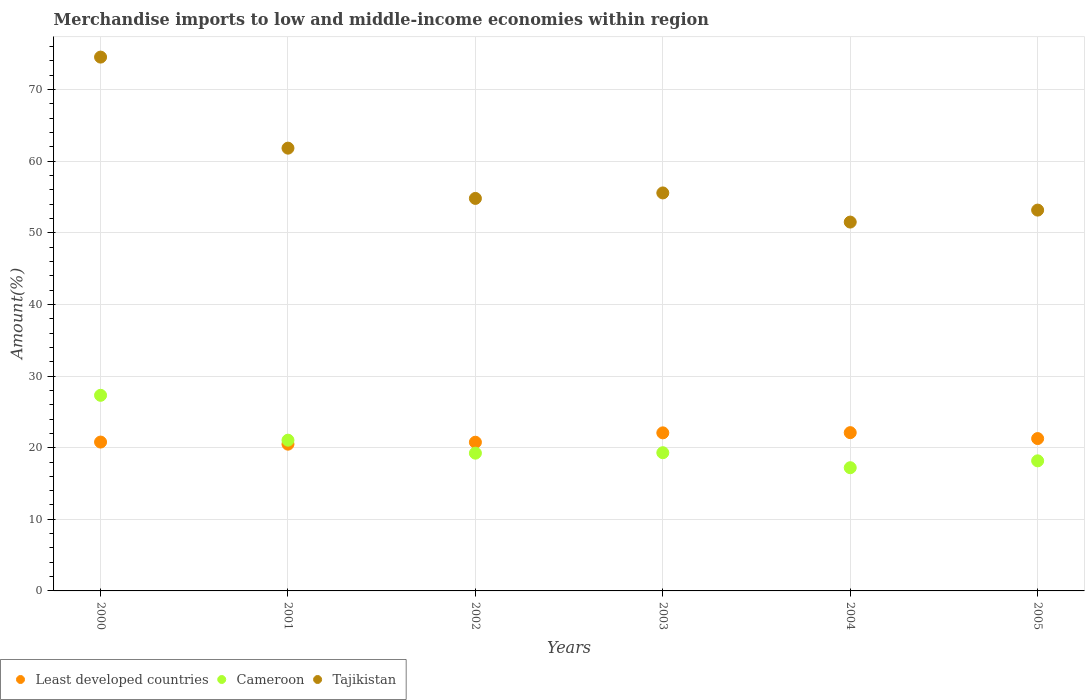Is the number of dotlines equal to the number of legend labels?
Ensure brevity in your answer.  Yes. What is the percentage of amount earned from merchandise imports in Cameroon in 2002?
Your answer should be very brief. 19.24. Across all years, what is the maximum percentage of amount earned from merchandise imports in Least developed countries?
Ensure brevity in your answer.  22.1. Across all years, what is the minimum percentage of amount earned from merchandise imports in Cameroon?
Offer a very short reply. 17.21. In which year was the percentage of amount earned from merchandise imports in Tajikistan maximum?
Ensure brevity in your answer.  2000. What is the total percentage of amount earned from merchandise imports in Cameroon in the graph?
Your response must be concise. 122.27. What is the difference between the percentage of amount earned from merchandise imports in Cameroon in 2001 and that in 2002?
Provide a succinct answer. 1.81. What is the difference between the percentage of amount earned from merchandise imports in Tajikistan in 2002 and the percentage of amount earned from merchandise imports in Least developed countries in 2000?
Provide a short and direct response. 34.02. What is the average percentage of amount earned from merchandise imports in Least developed countries per year?
Your answer should be very brief. 21.25. In the year 2002, what is the difference between the percentage of amount earned from merchandise imports in Tajikistan and percentage of amount earned from merchandise imports in Cameroon?
Your answer should be very brief. 35.57. What is the ratio of the percentage of amount earned from merchandise imports in Least developed countries in 2002 to that in 2004?
Your response must be concise. 0.94. Is the difference between the percentage of amount earned from merchandise imports in Tajikistan in 2001 and 2005 greater than the difference between the percentage of amount earned from merchandise imports in Cameroon in 2001 and 2005?
Ensure brevity in your answer.  Yes. What is the difference between the highest and the second highest percentage of amount earned from merchandise imports in Tajikistan?
Offer a very short reply. 12.71. What is the difference between the highest and the lowest percentage of amount earned from merchandise imports in Cameroon?
Provide a succinct answer. 10.11. Is the sum of the percentage of amount earned from merchandise imports in Least developed countries in 2001 and 2004 greater than the maximum percentage of amount earned from merchandise imports in Cameroon across all years?
Provide a succinct answer. Yes. Is it the case that in every year, the sum of the percentage of amount earned from merchandise imports in Cameroon and percentage of amount earned from merchandise imports in Tajikistan  is greater than the percentage of amount earned from merchandise imports in Least developed countries?
Provide a short and direct response. Yes. Is the percentage of amount earned from merchandise imports in Least developed countries strictly greater than the percentage of amount earned from merchandise imports in Cameroon over the years?
Make the answer very short. No. How many dotlines are there?
Your answer should be very brief. 3. How many years are there in the graph?
Your response must be concise. 6. What is the difference between two consecutive major ticks on the Y-axis?
Ensure brevity in your answer.  10. Does the graph contain any zero values?
Provide a succinct answer. No. How are the legend labels stacked?
Offer a very short reply. Horizontal. What is the title of the graph?
Your answer should be compact. Merchandise imports to low and middle-income economies within region. Does "Kyrgyz Republic" appear as one of the legend labels in the graph?
Provide a short and direct response. No. What is the label or title of the Y-axis?
Ensure brevity in your answer.  Amount(%). What is the Amount(%) in Least developed countries in 2000?
Provide a short and direct response. 20.79. What is the Amount(%) in Cameroon in 2000?
Offer a terse response. 27.32. What is the Amount(%) of Tajikistan in 2000?
Offer a very short reply. 74.54. What is the Amount(%) of Least developed countries in 2001?
Give a very brief answer. 20.49. What is the Amount(%) in Cameroon in 2001?
Keep it short and to the point. 21.05. What is the Amount(%) of Tajikistan in 2001?
Provide a succinct answer. 61.83. What is the Amount(%) of Least developed countries in 2002?
Offer a very short reply. 20.76. What is the Amount(%) of Cameroon in 2002?
Ensure brevity in your answer.  19.24. What is the Amount(%) of Tajikistan in 2002?
Your answer should be compact. 54.81. What is the Amount(%) of Least developed countries in 2003?
Your response must be concise. 22.07. What is the Amount(%) of Cameroon in 2003?
Your answer should be very brief. 19.3. What is the Amount(%) in Tajikistan in 2003?
Give a very brief answer. 55.57. What is the Amount(%) in Least developed countries in 2004?
Make the answer very short. 22.1. What is the Amount(%) of Cameroon in 2004?
Provide a short and direct response. 17.21. What is the Amount(%) in Tajikistan in 2004?
Your answer should be compact. 51.5. What is the Amount(%) of Least developed countries in 2005?
Offer a very short reply. 21.28. What is the Amount(%) of Cameroon in 2005?
Keep it short and to the point. 18.17. What is the Amount(%) in Tajikistan in 2005?
Ensure brevity in your answer.  53.18. Across all years, what is the maximum Amount(%) in Least developed countries?
Keep it short and to the point. 22.1. Across all years, what is the maximum Amount(%) of Cameroon?
Offer a very short reply. 27.32. Across all years, what is the maximum Amount(%) in Tajikistan?
Your answer should be compact. 74.54. Across all years, what is the minimum Amount(%) of Least developed countries?
Your response must be concise. 20.49. Across all years, what is the minimum Amount(%) in Cameroon?
Your answer should be very brief. 17.21. Across all years, what is the minimum Amount(%) of Tajikistan?
Provide a short and direct response. 51.5. What is the total Amount(%) in Least developed countries in the graph?
Keep it short and to the point. 127.49. What is the total Amount(%) of Cameroon in the graph?
Offer a terse response. 122.27. What is the total Amount(%) in Tajikistan in the graph?
Your response must be concise. 351.43. What is the difference between the Amount(%) in Least developed countries in 2000 and that in 2001?
Offer a very short reply. 0.29. What is the difference between the Amount(%) in Cameroon in 2000 and that in 2001?
Give a very brief answer. 6.27. What is the difference between the Amount(%) in Tajikistan in 2000 and that in 2001?
Give a very brief answer. 12.71. What is the difference between the Amount(%) in Least developed countries in 2000 and that in 2002?
Make the answer very short. 0.02. What is the difference between the Amount(%) in Cameroon in 2000 and that in 2002?
Your answer should be compact. 8.08. What is the difference between the Amount(%) in Tajikistan in 2000 and that in 2002?
Your answer should be compact. 19.73. What is the difference between the Amount(%) of Least developed countries in 2000 and that in 2003?
Offer a terse response. -1.29. What is the difference between the Amount(%) in Cameroon in 2000 and that in 2003?
Make the answer very short. 8.02. What is the difference between the Amount(%) of Tajikistan in 2000 and that in 2003?
Make the answer very short. 18.97. What is the difference between the Amount(%) of Least developed countries in 2000 and that in 2004?
Provide a succinct answer. -1.32. What is the difference between the Amount(%) in Cameroon in 2000 and that in 2004?
Provide a short and direct response. 10.11. What is the difference between the Amount(%) of Tajikistan in 2000 and that in 2004?
Keep it short and to the point. 23.04. What is the difference between the Amount(%) in Least developed countries in 2000 and that in 2005?
Your answer should be compact. -0.49. What is the difference between the Amount(%) in Cameroon in 2000 and that in 2005?
Make the answer very short. 9.15. What is the difference between the Amount(%) in Tajikistan in 2000 and that in 2005?
Keep it short and to the point. 21.36. What is the difference between the Amount(%) in Least developed countries in 2001 and that in 2002?
Give a very brief answer. -0.27. What is the difference between the Amount(%) of Cameroon in 2001 and that in 2002?
Offer a terse response. 1.81. What is the difference between the Amount(%) in Tajikistan in 2001 and that in 2002?
Provide a short and direct response. 7.02. What is the difference between the Amount(%) of Least developed countries in 2001 and that in 2003?
Provide a succinct answer. -1.58. What is the difference between the Amount(%) of Cameroon in 2001 and that in 2003?
Your answer should be very brief. 1.75. What is the difference between the Amount(%) of Tajikistan in 2001 and that in 2003?
Provide a short and direct response. 6.25. What is the difference between the Amount(%) of Least developed countries in 2001 and that in 2004?
Offer a very short reply. -1.61. What is the difference between the Amount(%) in Cameroon in 2001 and that in 2004?
Keep it short and to the point. 3.84. What is the difference between the Amount(%) of Tajikistan in 2001 and that in 2004?
Provide a succinct answer. 10.32. What is the difference between the Amount(%) in Least developed countries in 2001 and that in 2005?
Your answer should be very brief. -0.78. What is the difference between the Amount(%) in Cameroon in 2001 and that in 2005?
Your answer should be compact. 2.88. What is the difference between the Amount(%) of Tajikistan in 2001 and that in 2005?
Your answer should be compact. 8.65. What is the difference between the Amount(%) in Least developed countries in 2002 and that in 2003?
Ensure brevity in your answer.  -1.31. What is the difference between the Amount(%) in Cameroon in 2002 and that in 2003?
Keep it short and to the point. -0.06. What is the difference between the Amount(%) of Tajikistan in 2002 and that in 2003?
Provide a short and direct response. -0.77. What is the difference between the Amount(%) of Least developed countries in 2002 and that in 2004?
Your answer should be very brief. -1.34. What is the difference between the Amount(%) in Cameroon in 2002 and that in 2004?
Keep it short and to the point. 2.03. What is the difference between the Amount(%) of Tajikistan in 2002 and that in 2004?
Make the answer very short. 3.3. What is the difference between the Amount(%) in Least developed countries in 2002 and that in 2005?
Provide a succinct answer. -0.51. What is the difference between the Amount(%) of Cameroon in 2002 and that in 2005?
Ensure brevity in your answer.  1.07. What is the difference between the Amount(%) in Tajikistan in 2002 and that in 2005?
Keep it short and to the point. 1.63. What is the difference between the Amount(%) of Least developed countries in 2003 and that in 2004?
Offer a very short reply. -0.03. What is the difference between the Amount(%) of Cameroon in 2003 and that in 2004?
Your answer should be compact. 2.09. What is the difference between the Amount(%) in Tajikistan in 2003 and that in 2004?
Your response must be concise. 4.07. What is the difference between the Amount(%) of Least developed countries in 2003 and that in 2005?
Provide a short and direct response. 0.8. What is the difference between the Amount(%) of Cameroon in 2003 and that in 2005?
Your response must be concise. 1.13. What is the difference between the Amount(%) of Tajikistan in 2003 and that in 2005?
Your answer should be compact. 2.4. What is the difference between the Amount(%) of Least developed countries in 2004 and that in 2005?
Your response must be concise. 0.83. What is the difference between the Amount(%) in Cameroon in 2004 and that in 2005?
Provide a succinct answer. -0.96. What is the difference between the Amount(%) of Tajikistan in 2004 and that in 2005?
Give a very brief answer. -1.67. What is the difference between the Amount(%) of Least developed countries in 2000 and the Amount(%) of Cameroon in 2001?
Provide a succinct answer. -0.26. What is the difference between the Amount(%) of Least developed countries in 2000 and the Amount(%) of Tajikistan in 2001?
Provide a short and direct response. -41.04. What is the difference between the Amount(%) of Cameroon in 2000 and the Amount(%) of Tajikistan in 2001?
Your answer should be very brief. -34.51. What is the difference between the Amount(%) of Least developed countries in 2000 and the Amount(%) of Cameroon in 2002?
Provide a short and direct response. 1.55. What is the difference between the Amount(%) in Least developed countries in 2000 and the Amount(%) in Tajikistan in 2002?
Keep it short and to the point. -34.02. What is the difference between the Amount(%) of Cameroon in 2000 and the Amount(%) of Tajikistan in 2002?
Ensure brevity in your answer.  -27.49. What is the difference between the Amount(%) in Least developed countries in 2000 and the Amount(%) in Cameroon in 2003?
Provide a succinct answer. 1.49. What is the difference between the Amount(%) of Least developed countries in 2000 and the Amount(%) of Tajikistan in 2003?
Your answer should be very brief. -34.79. What is the difference between the Amount(%) in Cameroon in 2000 and the Amount(%) in Tajikistan in 2003?
Your answer should be very brief. -28.26. What is the difference between the Amount(%) of Least developed countries in 2000 and the Amount(%) of Cameroon in 2004?
Make the answer very short. 3.58. What is the difference between the Amount(%) of Least developed countries in 2000 and the Amount(%) of Tajikistan in 2004?
Ensure brevity in your answer.  -30.72. What is the difference between the Amount(%) of Cameroon in 2000 and the Amount(%) of Tajikistan in 2004?
Offer a very short reply. -24.19. What is the difference between the Amount(%) in Least developed countries in 2000 and the Amount(%) in Cameroon in 2005?
Your answer should be very brief. 2.62. What is the difference between the Amount(%) of Least developed countries in 2000 and the Amount(%) of Tajikistan in 2005?
Your answer should be compact. -32.39. What is the difference between the Amount(%) in Cameroon in 2000 and the Amount(%) in Tajikistan in 2005?
Provide a short and direct response. -25.86. What is the difference between the Amount(%) in Least developed countries in 2001 and the Amount(%) in Cameroon in 2002?
Keep it short and to the point. 1.26. What is the difference between the Amount(%) in Least developed countries in 2001 and the Amount(%) in Tajikistan in 2002?
Offer a terse response. -34.32. What is the difference between the Amount(%) of Cameroon in 2001 and the Amount(%) of Tajikistan in 2002?
Make the answer very short. -33.76. What is the difference between the Amount(%) in Least developed countries in 2001 and the Amount(%) in Cameroon in 2003?
Your response must be concise. 1.19. What is the difference between the Amount(%) of Least developed countries in 2001 and the Amount(%) of Tajikistan in 2003?
Ensure brevity in your answer.  -35.08. What is the difference between the Amount(%) in Cameroon in 2001 and the Amount(%) in Tajikistan in 2003?
Keep it short and to the point. -34.52. What is the difference between the Amount(%) in Least developed countries in 2001 and the Amount(%) in Cameroon in 2004?
Offer a very short reply. 3.29. What is the difference between the Amount(%) of Least developed countries in 2001 and the Amount(%) of Tajikistan in 2004?
Offer a very short reply. -31.01. What is the difference between the Amount(%) of Cameroon in 2001 and the Amount(%) of Tajikistan in 2004?
Make the answer very short. -30.45. What is the difference between the Amount(%) of Least developed countries in 2001 and the Amount(%) of Cameroon in 2005?
Make the answer very short. 2.33. What is the difference between the Amount(%) of Least developed countries in 2001 and the Amount(%) of Tajikistan in 2005?
Provide a short and direct response. -32.68. What is the difference between the Amount(%) of Cameroon in 2001 and the Amount(%) of Tajikistan in 2005?
Keep it short and to the point. -32.13. What is the difference between the Amount(%) of Least developed countries in 2002 and the Amount(%) of Cameroon in 2003?
Offer a very short reply. 1.46. What is the difference between the Amount(%) in Least developed countries in 2002 and the Amount(%) in Tajikistan in 2003?
Ensure brevity in your answer.  -34.81. What is the difference between the Amount(%) in Cameroon in 2002 and the Amount(%) in Tajikistan in 2003?
Provide a short and direct response. -36.34. What is the difference between the Amount(%) in Least developed countries in 2002 and the Amount(%) in Cameroon in 2004?
Provide a succinct answer. 3.56. What is the difference between the Amount(%) in Least developed countries in 2002 and the Amount(%) in Tajikistan in 2004?
Provide a short and direct response. -30.74. What is the difference between the Amount(%) of Cameroon in 2002 and the Amount(%) of Tajikistan in 2004?
Your answer should be very brief. -32.27. What is the difference between the Amount(%) of Least developed countries in 2002 and the Amount(%) of Cameroon in 2005?
Give a very brief answer. 2.6. What is the difference between the Amount(%) of Least developed countries in 2002 and the Amount(%) of Tajikistan in 2005?
Your response must be concise. -32.41. What is the difference between the Amount(%) in Cameroon in 2002 and the Amount(%) in Tajikistan in 2005?
Make the answer very short. -33.94. What is the difference between the Amount(%) of Least developed countries in 2003 and the Amount(%) of Cameroon in 2004?
Offer a very short reply. 4.87. What is the difference between the Amount(%) of Least developed countries in 2003 and the Amount(%) of Tajikistan in 2004?
Keep it short and to the point. -29.43. What is the difference between the Amount(%) in Cameroon in 2003 and the Amount(%) in Tajikistan in 2004?
Ensure brevity in your answer.  -32.21. What is the difference between the Amount(%) of Least developed countries in 2003 and the Amount(%) of Cameroon in 2005?
Ensure brevity in your answer.  3.91. What is the difference between the Amount(%) in Least developed countries in 2003 and the Amount(%) in Tajikistan in 2005?
Provide a succinct answer. -31.1. What is the difference between the Amount(%) in Cameroon in 2003 and the Amount(%) in Tajikistan in 2005?
Ensure brevity in your answer.  -33.88. What is the difference between the Amount(%) of Least developed countries in 2004 and the Amount(%) of Cameroon in 2005?
Provide a succinct answer. 3.94. What is the difference between the Amount(%) in Least developed countries in 2004 and the Amount(%) in Tajikistan in 2005?
Your response must be concise. -31.07. What is the difference between the Amount(%) in Cameroon in 2004 and the Amount(%) in Tajikistan in 2005?
Ensure brevity in your answer.  -35.97. What is the average Amount(%) of Least developed countries per year?
Offer a very short reply. 21.25. What is the average Amount(%) in Cameroon per year?
Your response must be concise. 20.38. What is the average Amount(%) of Tajikistan per year?
Make the answer very short. 58.57. In the year 2000, what is the difference between the Amount(%) of Least developed countries and Amount(%) of Cameroon?
Your answer should be compact. -6.53. In the year 2000, what is the difference between the Amount(%) in Least developed countries and Amount(%) in Tajikistan?
Offer a very short reply. -53.76. In the year 2000, what is the difference between the Amount(%) of Cameroon and Amount(%) of Tajikistan?
Offer a terse response. -47.23. In the year 2001, what is the difference between the Amount(%) of Least developed countries and Amount(%) of Cameroon?
Offer a very short reply. -0.56. In the year 2001, what is the difference between the Amount(%) of Least developed countries and Amount(%) of Tajikistan?
Offer a terse response. -41.33. In the year 2001, what is the difference between the Amount(%) of Cameroon and Amount(%) of Tajikistan?
Your response must be concise. -40.78. In the year 2002, what is the difference between the Amount(%) of Least developed countries and Amount(%) of Cameroon?
Keep it short and to the point. 1.53. In the year 2002, what is the difference between the Amount(%) of Least developed countries and Amount(%) of Tajikistan?
Provide a short and direct response. -34.05. In the year 2002, what is the difference between the Amount(%) in Cameroon and Amount(%) in Tajikistan?
Make the answer very short. -35.57. In the year 2003, what is the difference between the Amount(%) of Least developed countries and Amount(%) of Cameroon?
Give a very brief answer. 2.77. In the year 2003, what is the difference between the Amount(%) of Least developed countries and Amount(%) of Tajikistan?
Make the answer very short. -33.5. In the year 2003, what is the difference between the Amount(%) in Cameroon and Amount(%) in Tajikistan?
Provide a short and direct response. -36.28. In the year 2004, what is the difference between the Amount(%) of Least developed countries and Amount(%) of Cameroon?
Keep it short and to the point. 4.9. In the year 2004, what is the difference between the Amount(%) in Least developed countries and Amount(%) in Tajikistan?
Your answer should be compact. -29.4. In the year 2004, what is the difference between the Amount(%) in Cameroon and Amount(%) in Tajikistan?
Ensure brevity in your answer.  -34.3. In the year 2005, what is the difference between the Amount(%) of Least developed countries and Amount(%) of Cameroon?
Offer a terse response. 3.11. In the year 2005, what is the difference between the Amount(%) of Least developed countries and Amount(%) of Tajikistan?
Give a very brief answer. -31.9. In the year 2005, what is the difference between the Amount(%) of Cameroon and Amount(%) of Tajikistan?
Keep it short and to the point. -35.01. What is the ratio of the Amount(%) of Least developed countries in 2000 to that in 2001?
Give a very brief answer. 1.01. What is the ratio of the Amount(%) in Cameroon in 2000 to that in 2001?
Ensure brevity in your answer.  1.3. What is the ratio of the Amount(%) in Tajikistan in 2000 to that in 2001?
Make the answer very short. 1.21. What is the ratio of the Amount(%) of Cameroon in 2000 to that in 2002?
Ensure brevity in your answer.  1.42. What is the ratio of the Amount(%) of Tajikistan in 2000 to that in 2002?
Your response must be concise. 1.36. What is the ratio of the Amount(%) of Least developed countries in 2000 to that in 2003?
Your answer should be compact. 0.94. What is the ratio of the Amount(%) in Cameroon in 2000 to that in 2003?
Make the answer very short. 1.42. What is the ratio of the Amount(%) in Tajikistan in 2000 to that in 2003?
Provide a short and direct response. 1.34. What is the ratio of the Amount(%) in Least developed countries in 2000 to that in 2004?
Provide a short and direct response. 0.94. What is the ratio of the Amount(%) of Cameroon in 2000 to that in 2004?
Keep it short and to the point. 1.59. What is the ratio of the Amount(%) of Tajikistan in 2000 to that in 2004?
Give a very brief answer. 1.45. What is the ratio of the Amount(%) in Least developed countries in 2000 to that in 2005?
Provide a short and direct response. 0.98. What is the ratio of the Amount(%) in Cameroon in 2000 to that in 2005?
Your response must be concise. 1.5. What is the ratio of the Amount(%) in Tajikistan in 2000 to that in 2005?
Your response must be concise. 1.4. What is the ratio of the Amount(%) of Cameroon in 2001 to that in 2002?
Provide a succinct answer. 1.09. What is the ratio of the Amount(%) of Tajikistan in 2001 to that in 2002?
Make the answer very short. 1.13. What is the ratio of the Amount(%) in Least developed countries in 2001 to that in 2003?
Offer a very short reply. 0.93. What is the ratio of the Amount(%) in Cameroon in 2001 to that in 2003?
Your response must be concise. 1.09. What is the ratio of the Amount(%) of Tajikistan in 2001 to that in 2003?
Make the answer very short. 1.11. What is the ratio of the Amount(%) of Least developed countries in 2001 to that in 2004?
Your answer should be very brief. 0.93. What is the ratio of the Amount(%) in Cameroon in 2001 to that in 2004?
Provide a succinct answer. 1.22. What is the ratio of the Amount(%) in Tajikistan in 2001 to that in 2004?
Give a very brief answer. 1.2. What is the ratio of the Amount(%) of Least developed countries in 2001 to that in 2005?
Give a very brief answer. 0.96. What is the ratio of the Amount(%) in Cameroon in 2001 to that in 2005?
Your response must be concise. 1.16. What is the ratio of the Amount(%) of Tajikistan in 2001 to that in 2005?
Give a very brief answer. 1.16. What is the ratio of the Amount(%) of Least developed countries in 2002 to that in 2003?
Make the answer very short. 0.94. What is the ratio of the Amount(%) in Cameroon in 2002 to that in 2003?
Give a very brief answer. 1. What is the ratio of the Amount(%) of Tajikistan in 2002 to that in 2003?
Keep it short and to the point. 0.99. What is the ratio of the Amount(%) in Least developed countries in 2002 to that in 2004?
Your answer should be compact. 0.94. What is the ratio of the Amount(%) in Cameroon in 2002 to that in 2004?
Your response must be concise. 1.12. What is the ratio of the Amount(%) in Tajikistan in 2002 to that in 2004?
Keep it short and to the point. 1.06. What is the ratio of the Amount(%) of Least developed countries in 2002 to that in 2005?
Your answer should be very brief. 0.98. What is the ratio of the Amount(%) of Cameroon in 2002 to that in 2005?
Provide a succinct answer. 1.06. What is the ratio of the Amount(%) of Tajikistan in 2002 to that in 2005?
Ensure brevity in your answer.  1.03. What is the ratio of the Amount(%) of Cameroon in 2003 to that in 2004?
Make the answer very short. 1.12. What is the ratio of the Amount(%) of Tajikistan in 2003 to that in 2004?
Your answer should be very brief. 1.08. What is the ratio of the Amount(%) of Least developed countries in 2003 to that in 2005?
Provide a short and direct response. 1.04. What is the ratio of the Amount(%) in Cameroon in 2003 to that in 2005?
Offer a terse response. 1.06. What is the ratio of the Amount(%) of Tajikistan in 2003 to that in 2005?
Give a very brief answer. 1.05. What is the ratio of the Amount(%) of Least developed countries in 2004 to that in 2005?
Provide a short and direct response. 1.04. What is the ratio of the Amount(%) of Cameroon in 2004 to that in 2005?
Your answer should be compact. 0.95. What is the ratio of the Amount(%) of Tajikistan in 2004 to that in 2005?
Your answer should be very brief. 0.97. What is the difference between the highest and the second highest Amount(%) of Least developed countries?
Give a very brief answer. 0.03. What is the difference between the highest and the second highest Amount(%) in Cameroon?
Ensure brevity in your answer.  6.27. What is the difference between the highest and the second highest Amount(%) in Tajikistan?
Offer a very short reply. 12.71. What is the difference between the highest and the lowest Amount(%) in Least developed countries?
Keep it short and to the point. 1.61. What is the difference between the highest and the lowest Amount(%) of Cameroon?
Keep it short and to the point. 10.11. What is the difference between the highest and the lowest Amount(%) of Tajikistan?
Your answer should be compact. 23.04. 